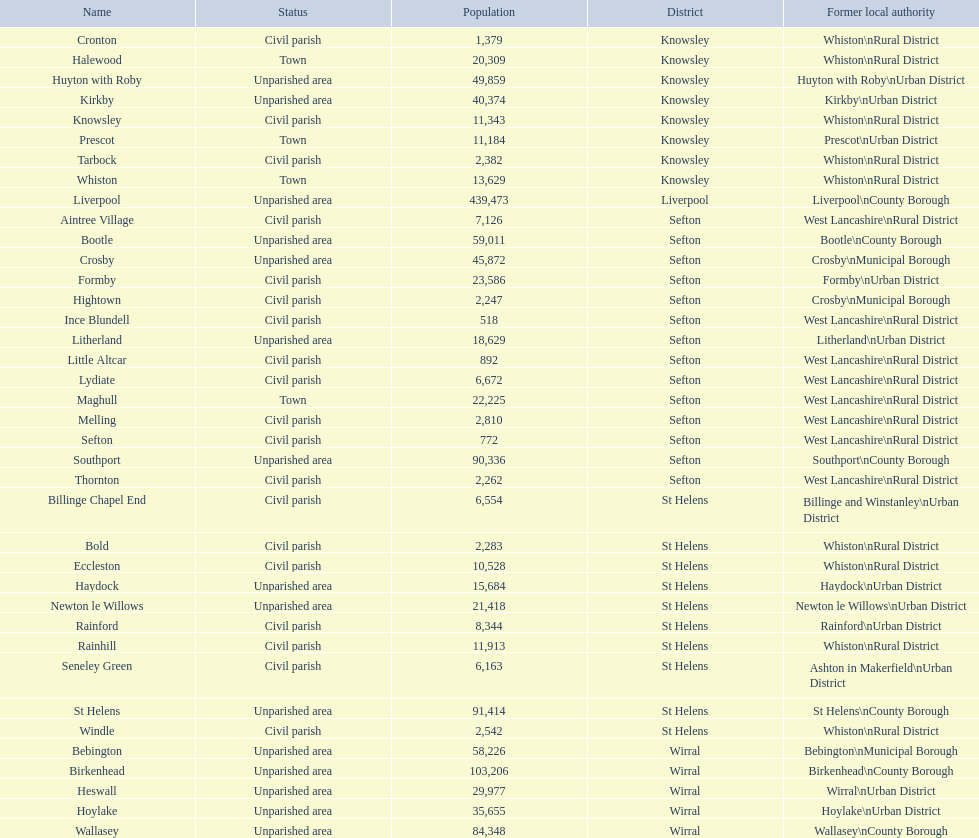Could you parse the entire table as a dict? {'header': ['Name', 'Status', 'Population', 'District', 'Former local authority'], 'rows': [['Cronton', 'Civil parish', '1,379', 'Knowsley', 'Whiston\\nRural District'], ['Halewood', 'Town', '20,309', 'Knowsley', 'Whiston\\nRural District'], ['Huyton with Roby', 'Unparished area', '49,859', 'Knowsley', 'Huyton with Roby\\nUrban District'], ['Kirkby', 'Unparished area', '40,374', 'Knowsley', 'Kirkby\\nUrban District'], ['Knowsley', 'Civil parish', '11,343', 'Knowsley', 'Whiston\\nRural District'], ['Prescot', 'Town', '11,184', 'Knowsley', 'Prescot\\nUrban District'], ['Tarbock', 'Civil parish', '2,382', 'Knowsley', 'Whiston\\nRural District'], ['Whiston', 'Town', '13,629', 'Knowsley', 'Whiston\\nRural District'], ['Liverpool', 'Unparished area', '439,473', 'Liverpool', 'Liverpool\\nCounty Borough'], ['Aintree Village', 'Civil parish', '7,126', 'Sefton', 'West Lancashire\\nRural District'], ['Bootle', 'Unparished area', '59,011', 'Sefton', 'Bootle\\nCounty Borough'], ['Crosby', 'Unparished area', '45,872', 'Sefton', 'Crosby\\nMunicipal Borough'], ['Formby', 'Civil parish', '23,586', 'Sefton', 'Formby\\nUrban District'], ['Hightown', 'Civil parish', '2,247', 'Sefton', 'Crosby\\nMunicipal Borough'], ['Ince Blundell', 'Civil parish', '518', 'Sefton', 'West Lancashire\\nRural District'], ['Litherland', 'Unparished area', '18,629', 'Sefton', 'Litherland\\nUrban District'], ['Little Altcar', 'Civil parish', '892', 'Sefton', 'West Lancashire\\nRural District'], ['Lydiate', 'Civil parish', '6,672', 'Sefton', 'West Lancashire\\nRural District'], ['Maghull', 'Town', '22,225', 'Sefton', 'West Lancashire\\nRural District'], ['Melling', 'Civil parish', '2,810', 'Sefton', 'West Lancashire\\nRural District'], ['Sefton', 'Civil parish', '772', 'Sefton', 'West Lancashire\\nRural District'], ['Southport', 'Unparished area', '90,336', 'Sefton', 'Southport\\nCounty Borough'], ['Thornton', 'Civil parish', '2,262', 'Sefton', 'West Lancashire\\nRural District'], ['Billinge Chapel End', 'Civil parish', '6,554', 'St Helens', 'Billinge and Winstanley\\nUrban District'], ['Bold', 'Civil parish', '2,283', 'St Helens', 'Whiston\\nRural District'], ['Eccleston', 'Civil parish', '10,528', 'St Helens', 'Whiston\\nRural District'], ['Haydock', 'Unparished area', '15,684', 'St Helens', 'Haydock\\nUrban District'], ['Newton le Willows', 'Unparished area', '21,418', 'St Helens', 'Newton le Willows\\nUrban District'], ['Rainford', 'Civil parish', '8,344', 'St Helens', 'Rainford\\nUrban District'], ['Rainhill', 'Civil parish', '11,913', 'St Helens', 'Whiston\\nRural District'], ['Seneley Green', 'Civil parish', '6,163', 'St Helens', 'Ashton in Makerfield\\nUrban District'], ['St Helens', 'Unparished area', '91,414', 'St Helens', 'St Helens\\nCounty Borough'], ['Windle', 'Civil parish', '2,542', 'St Helens', 'Whiston\\nRural District'], ['Bebington', 'Unparished area', '58,226', 'Wirral', 'Bebington\\nMunicipal Borough'], ['Birkenhead', 'Unparished area', '103,206', 'Wirral', 'Birkenhead\\nCounty Borough'], ['Heswall', 'Unparished area', '29,977', 'Wirral', 'Wirral\\nUrban District'], ['Hoylake', 'Unparished area', '35,655', 'Wirral', 'Hoylake\\nUrban District'], ['Wallasey', 'Unparished area', '84,348', 'Wirral', 'Wallasey\\nCounty Borough']]} How many regions are unparished zones? 15. 